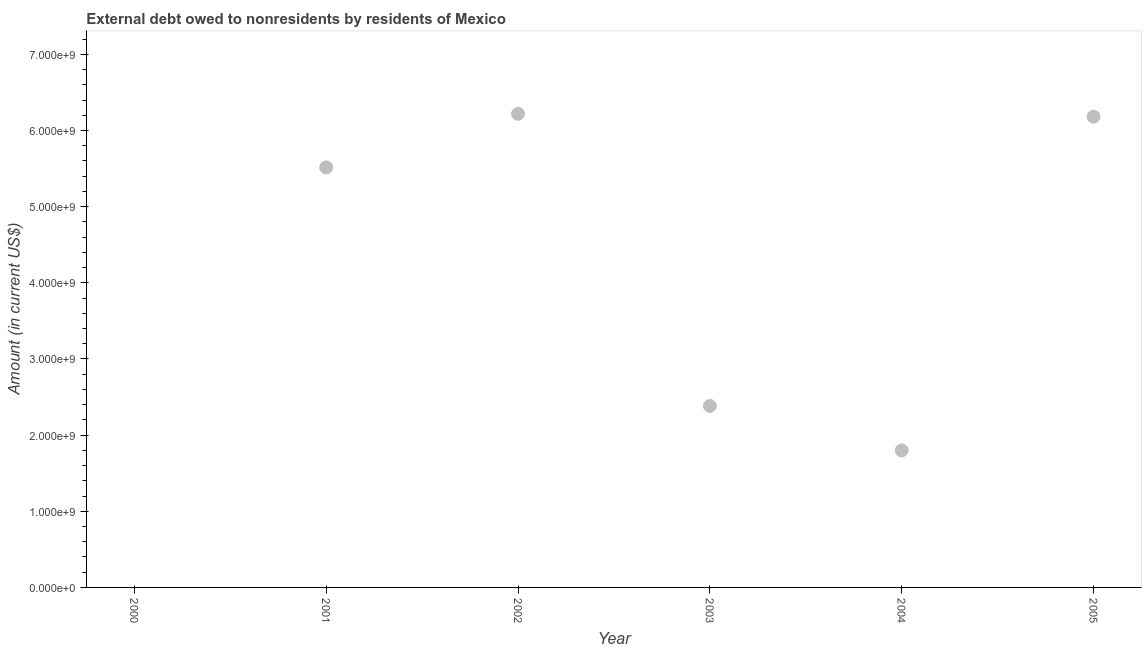What is the debt in 2003?
Offer a terse response. 2.38e+09. Across all years, what is the maximum debt?
Ensure brevity in your answer.  6.22e+09. What is the sum of the debt?
Provide a succinct answer. 2.21e+1. What is the difference between the debt in 2001 and 2002?
Provide a succinct answer. -7.04e+08. What is the average debt per year?
Make the answer very short. 3.68e+09. What is the median debt?
Ensure brevity in your answer.  3.95e+09. What is the ratio of the debt in 2002 to that in 2005?
Provide a succinct answer. 1.01. Is the debt in 2002 less than that in 2003?
Offer a very short reply. No. What is the difference between the highest and the second highest debt?
Your answer should be very brief. 3.88e+07. What is the difference between the highest and the lowest debt?
Your answer should be compact. 6.22e+09. Does the debt monotonically increase over the years?
Provide a succinct answer. No. How many dotlines are there?
Provide a succinct answer. 1. What is the difference between two consecutive major ticks on the Y-axis?
Provide a short and direct response. 1.00e+09. Does the graph contain any zero values?
Give a very brief answer. Yes. What is the title of the graph?
Make the answer very short. External debt owed to nonresidents by residents of Mexico. What is the Amount (in current US$) in 2000?
Give a very brief answer. 0. What is the Amount (in current US$) in 2001?
Your response must be concise. 5.52e+09. What is the Amount (in current US$) in 2002?
Your answer should be very brief. 6.22e+09. What is the Amount (in current US$) in 2003?
Your response must be concise. 2.38e+09. What is the Amount (in current US$) in 2004?
Offer a terse response. 1.80e+09. What is the Amount (in current US$) in 2005?
Offer a terse response. 6.18e+09. What is the difference between the Amount (in current US$) in 2001 and 2002?
Keep it short and to the point. -7.04e+08. What is the difference between the Amount (in current US$) in 2001 and 2003?
Offer a terse response. 3.13e+09. What is the difference between the Amount (in current US$) in 2001 and 2004?
Offer a terse response. 3.72e+09. What is the difference between the Amount (in current US$) in 2001 and 2005?
Provide a succinct answer. -6.65e+08. What is the difference between the Amount (in current US$) in 2002 and 2003?
Keep it short and to the point. 3.84e+09. What is the difference between the Amount (in current US$) in 2002 and 2004?
Keep it short and to the point. 4.42e+09. What is the difference between the Amount (in current US$) in 2002 and 2005?
Your answer should be very brief. 3.88e+07. What is the difference between the Amount (in current US$) in 2003 and 2004?
Ensure brevity in your answer.  5.84e+08. What is the difference between the Amount (in current US$) in 2003 and 2005?
Keep it short and to the point. -3.80e+09. What is the difference between the Amount (in current US$) in 2004 and 2005?
Your answer should be very brief. -4.38e+09. What is the ratio of the Amount (in current US$) in 2001 to that in 2002?
Ensure brevity in your answer.  0.89. What is the ratio of the Amount (in current US$) in 2001 to that in 2003?
Ensure brevity in your answer.  2.31. What is the ratio of the Amount (in current US$) in 2001 to that in 2004?
Keep it short and to the point. 3.07. What is the ratio of the Amount (in current US$) in 2001 to that in 2005?
Your response must be concise. 0.89. What is the ratio of the Amount (in current US$) in 2002 to that in 2003?
Give a very brief answer. 2.61. What is the ratio of the Amount (in current US$) in 2002 to that in 2004?
Provide a succinct answer. 3.46. What is the ratio of the Amount (in current US$) in 2002 to that in 2005?
Your response must be concise. 1.01. What is the ratio of the Amount (in current US$) in 2003 to that in 2004?
Make the answer very short. 1.32. What is the ratio of the Amount (in current US$) in 2003 to that in 2005?
Keep it short and to the point. 0.39. What is the ratio of the Amount (in current US$) in 2004 to that in 2005?
Make the answer very short. 0.29. 